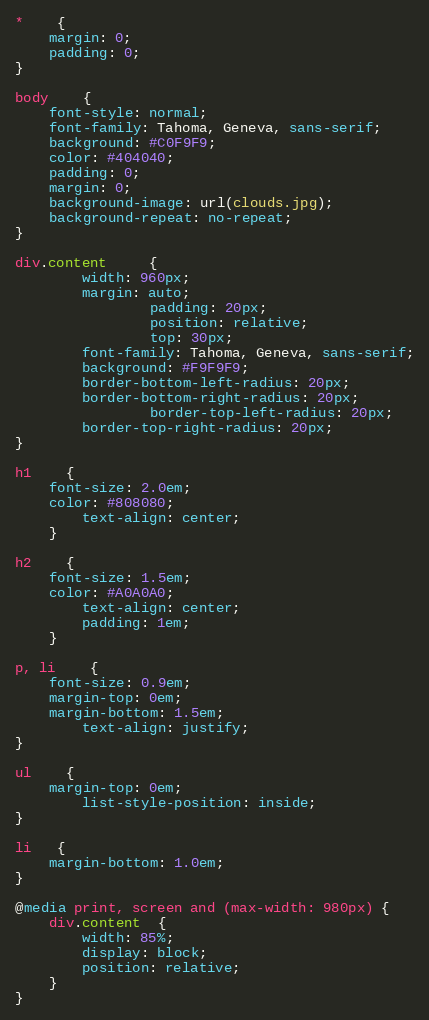Convert code to text. <code><loc_0><loc_0><loc_500><loc_500><_CSS_>* 	{ 
	margin: 0;
	padding: 0;
}

body 	{ 
	font-style: normal;
	font-family: Tahoma, Geneva, sans-serif;
	background: #C0F9F9;
	color: #404040;
	padding: 0;
	margin: 0;
	background-image: url(clouds.jpg);
	background-repeat: no-repeat;
}

div.content     {
		width: 960px;
		margin: auto;
                padding: 20px;
                position: relative;
                top: 30px;
		font-family: Tahoma, Geneva, sans-serif;
		background: #F9F9F9;
		border-bottom-left-radius: 20px;
		border-bottom-right-radius: 20px;
                border-top-left-radius: 20px;
		border-top-right-radius: 20px;
}

h1	{
	font-size: 2.0em;
	color: #808080;
        text-align: center;
	}
	
h2	{
	font-size: 1.5em;
	color: #A0A0A0;
        text-align: center;
        padding: 1em;
	}

p, li	{
	font-size: 0.9em;
	margin-top: 0em;
	margin-bottom: 1.5em;
        text-align: justify;
}

ul	{
	margin-top: 0em;
        list-style-position: inside;
}

li   {
    margin-bottom: 1.0em;
}

@media print, screen and (max-width: 980px) {
    div.content  {
        width: 85%;
        display: block;
        position: relative;
    }
}
</code> 